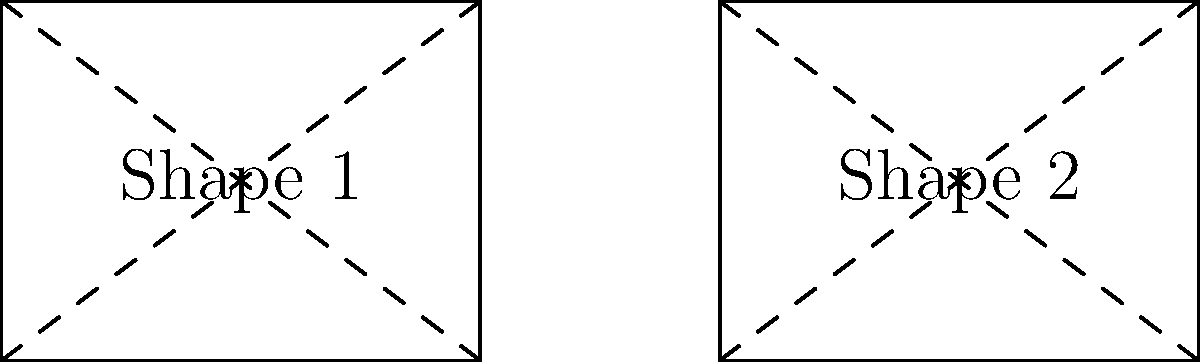In your latest YouTube video review of iconic Bollywood dance sequences, you're analyzing the geometric patterns formed by dancers. Two rectangular formations from different films are shown above. Are these shapes congruent? If so, explain which transformation(s) would map one onto the other. To determine if the shapes are congruent and identify the transformation(s), we need to follow these steps:

1. Compare the dimensions of both rectangles:
   Shape 1: 4 units wide, 3 units tall
   Shape 2: 4 units wide, 3 units tall

2. Since both rectangles have the same dimensions, they are congruent.

3. To map Shape 1 onto Shape 2, we need to:
   a) Translate (slide) Shape 1 to the right by 6 units.
   
4. No other transformations (rotation, reflection, or scaling) are necessary.

5. The congruence can be verified by the fact that:
   - Corresponding sides are equal in length
   - Corresponding angles are equal (all 90 degrees)
   - The diagonals of both rectangles are equal and bisect each other

In the context of dance formations, this means that the two groups of dancers form identical rectangular shapes, with one group positioned to the right of the other on the stage or in the film frame.
Answer: Yes, congruent. Translation 6 units right. 